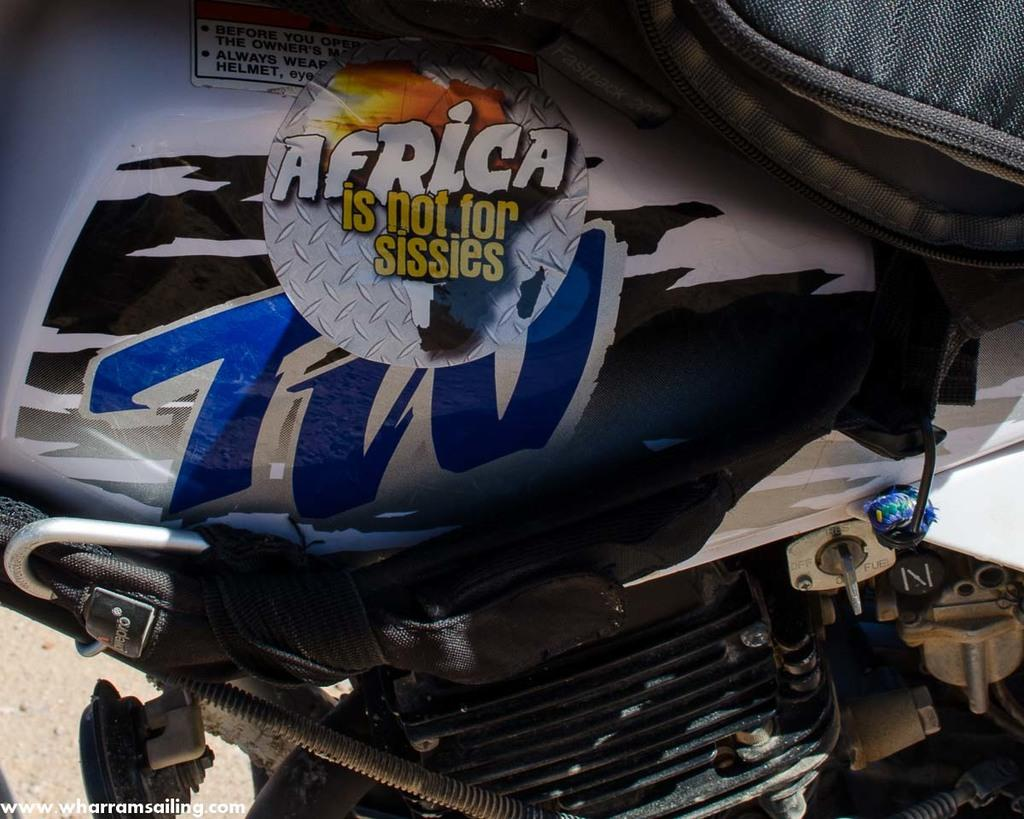What is the main subject of the zoomed in picture? The main subject of the zoomed in picture is a bike. What parts of the bike can be seen in the image? The engine and the tank of the bike are visible in the image. Are there any decorations on the tank? Yes, there are stickers on the tank. What is the background of the image? The path is visible in the image. Is there any text in the image? Yes, there is text in the bottom left corner of the image. How many legs can be seen supporting the bike in the image? There are no legs visible in the image; the bike is resting on its own wheels. Is the bike capable of flight in the image? The image does not depict the bike in flight; it is stationary on the path. 